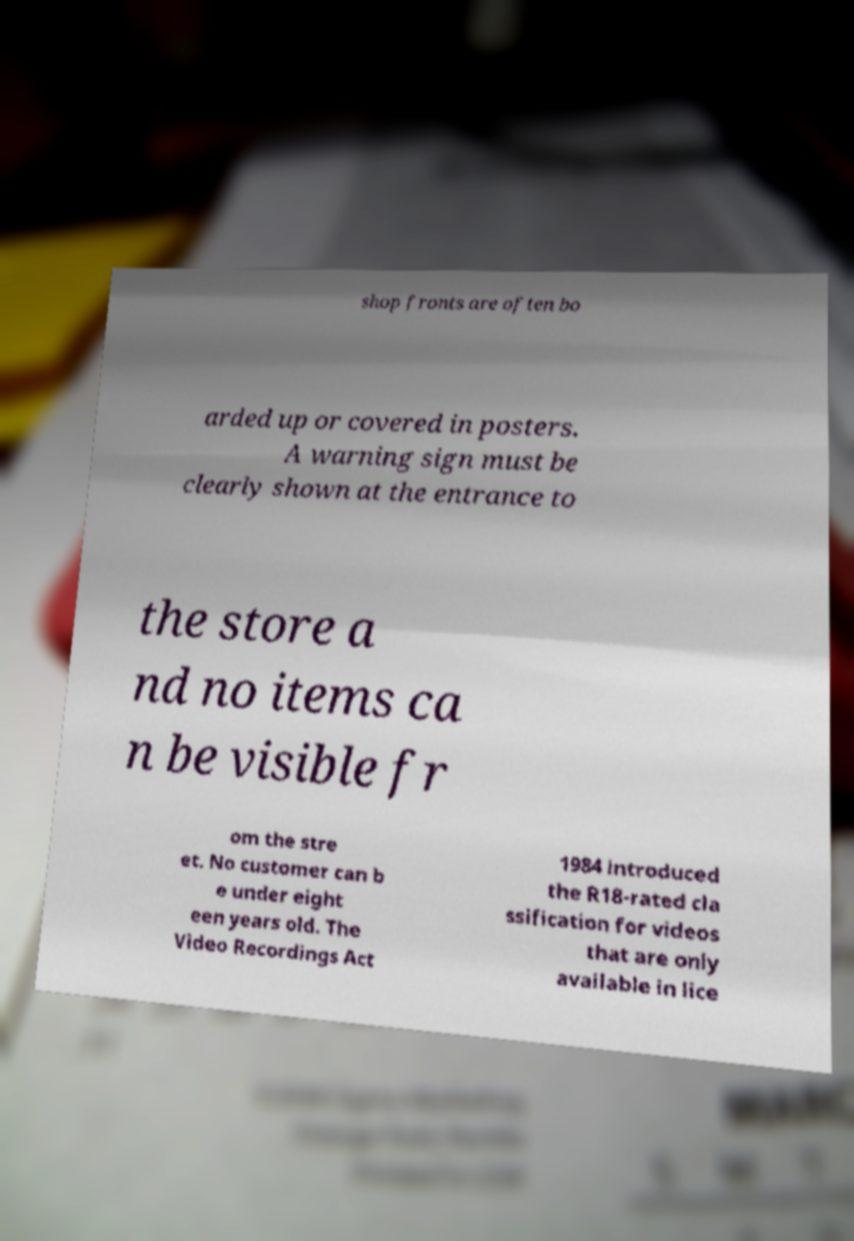Please identify and transcribe the text found in this image. shop fronts are often bo arded up or covered in posters. A warning sign must be clearly shown at the entrance to the store a nd no items ca n be visible fr om the stre et. No customer can b e under eight een years old. The Video Recordings Act 1984 introduced the R18-rated cla ssification for videos that are only available in lice 